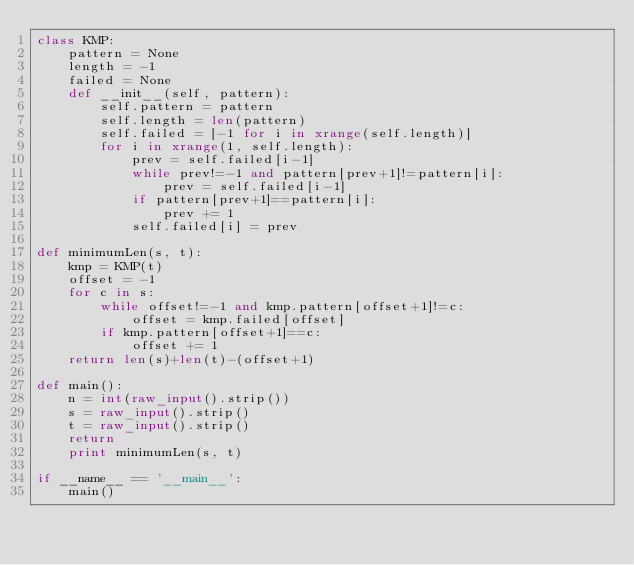<code> <loc_0><loc_0><loc_500><loc_500><_Python_>class KMP:
    pattern = None
    length = -1
    failed = None
    def __init__(self, pattern):
        self.pattern = pattern
        self.length = len(pattern)
        self.failed = [-1 for i in xrange(self.length)]
        for i in xrange(1, self.length):
            prev = self.failed[i-1]
            while prev!=-1 and pattern[prev+1]!=pattern[i]:
                prev = self.failed[i-1]
            if pattern[prev+1]==pattern[i]:
                prev += 1
            self.failed[i] = prev

def minimumLen(s, t):
    kmp = KMP(t)
    offset = -1
    for c in s:
        while offset!=-1 and kmp.pattern[offset+1]!=c:
            offset = kmp.failed[offset]
        if kmp.pattern[offset+1]==c:
            offset += 1
    return len(s)+len(t)-(offset+1)

def main():
    n = int(raw_input().strip())
    s = raw_input().strip()
    t = raw_input().strip()
    return
    print minimumLen(s, t)

if __name__ == '__main__':
    main()</code> 